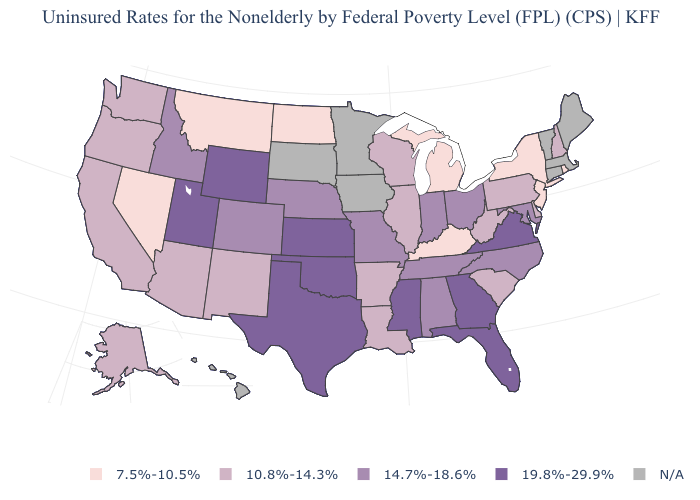What is the highest value in the MidWest ?
Short answer required. 19.8%-29.9%. Name the states that have a value in the range 19.8%-29.9%?
Quick response, please. Florida, Georgia, Kansas, Mississippi, Oklahoma, Texas, Utah, Virginia, Wyoming. What is the lowest value in the USA?
Answer briefly. 7.5%-10.5%. Does the map have missing data?
Quick response, please. Yes. Name the states that have a value in the range 7.5%-10.5%?
Answer briefly. Kentucky, Michigan, Montana, Nevada, New Jersey, New York, North Dakota, Rhode Island. What is the highest value in states that border Utah?
Be succinct. 19.8%-29.9%. What is the value of Florida?
Write a very short answer. 19.8%-29.9%. What is the value of Maine?
Be succinct. N/A. What is the lowest value in the USA?
Short answer required. 7.5%-10.5%. Name the states that have a value in the range N/A?
Answer briefly. Connecticut, Hawaii, Iowa, Maine, Massachusetts, Minnesota, South Dakota, Vermont. Name the states that have a value in the range N/A?
Concise answer only. Connecticut, Hawaii, Iowa, Maine, Massachusetts, Minnesota, South Dakota, Vermont. Does New York have the lowest value in the Northeast?
Short answer required. Yes. 